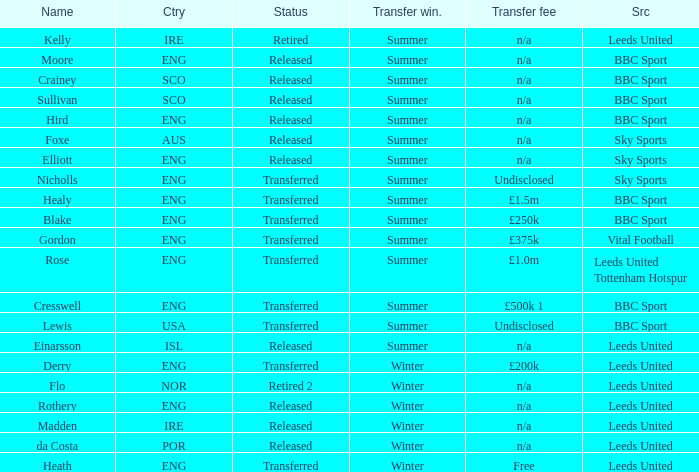What was the transfer fee for the summer transfer involving the SCO named Crainey? N/a. Can you parse all the data within this table? {'header': ['Name', 'Ctry', 'Status', 'Transfer win.', 'Transfer fee', 'Src'], 'rows': [['Kelly', 'IRE', 'Retired', 'Summer', 'n/a', 'Leeds United'], ['Moore', 'ENG', 'Released', 'Summer', 'n/a', 'BBC Sport'], ['Crainey', 'SCO', 'Released', 'Summer', 'n/a', 'BBC Sport'], ['Sullivan', 'SCO', 'Released', 'Summer', 'n/a', 'BBC Sport'], ['Hird', 'ENG', 'Released', 'Summer', 'n/a', 'BBC Sport'], ['Foxe', 'AUS', 'Released', 'Summer', 'n/a', 'Sky Sports'], ['Elliott', 'ENG', 'Released', 'Summer', 'n/a', 'Sky Sports'], ['Nicholls', 'ENG', 'Transferred', 'Summer', 'Undisclosed', 'Sky Sports'], ['Healy', 'ENG', 'Transferred', 'Summer', '£1.5m', 'BBC Sport'], ['Blake', 'ENG', 'Transferred', 'Summer', '£250k', 'BBC Sport'], ['Gordon', 'ENG', 'Transferred', 'Summer', '£375k', 'Vital Football'], ['Rose', 'ENG', 'Transferred', 'Summer', '£1.0m', 'Leeds United Tottenham Hotspur'], ['Cresswell', 'ENG', 'Transferred', 'Summer', '£500k 1', 'BBC Sport'], ['Lewis', 'USA', 'Transferred', 'Summer', 'Undisclosed', 'BBC Sport'], ['Einarsson', 'ISL', 'Released', 'Summer', 'n/a', 'Leeds United'], ['Derry', 'ENG', 'Transferred', 'Winter', '£200k', 'Leeds United'], ['Flo', 'NOR', 'Retired 2', 'Winter', 'n/a', 'Leeds United'], ['Rothery', 'ENG', 'Released', 'Winter', 'n/a', 'Leeds United'], ['Madden', 'IRE', 'Released', 'Winter', 'n/a', 'Leeds United'], ['da Costa', 'POR', 'Released', 'Winter', 'n/a', 'Leeds United'], ['Heath', 'ENG', 'Transferred', 'Winter', 'Free', 'Leeds United']]} 